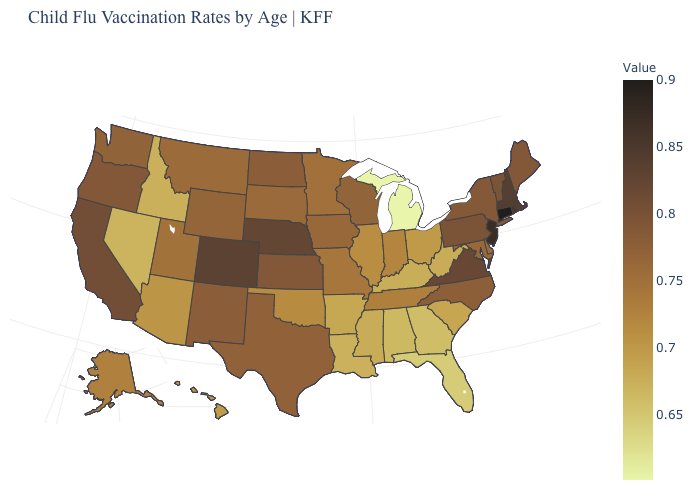Does Connecticut have the highest value in the USA?
Concise answer only. Yes. Does the map have missing data?
Answer briefly. No. 